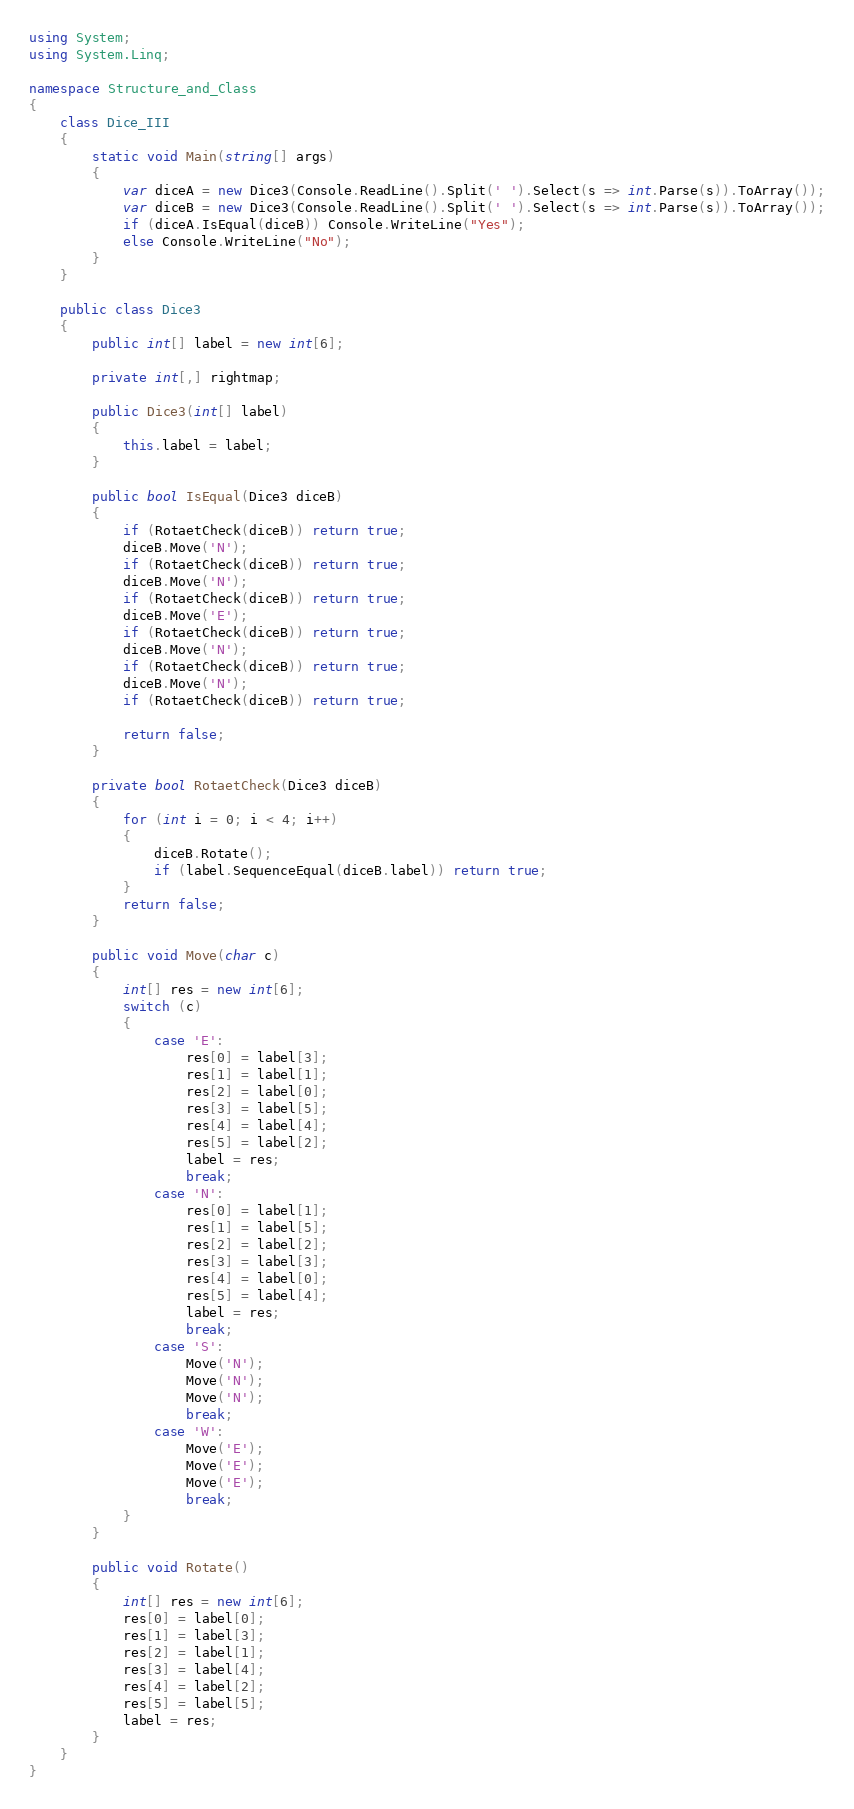Convert code to text. <code><loc_0><loc_0><loc_500><loc_500><_C#_>using System;
using System.Linq;

namespace Structure_and_Class
{
    class Dice_III
    {
        static void Main(string[] args)
        {
            var diceA = new Dice3(Console.ReadLine().Split(' ').Select(s => int.Parse(s)).ToArray());
            var diceB = new Dice3(Console.ReadLine().Split(' ').Select(s => int.Parse(s)).ToArray());
            if (diceA.IsEqual(diceB)) Console.WriteLine("Yes");
            else Console.WriteLine("No");
        }
    }

    public class Dice3
    {
        public int[] label = new int[6];

        private int[,] rightmap;

        public Dice3(int[] label)
        {
            this.label = label;
        }

        public bool IsEqual(Dice3 diceB)
        {
            if (RotaetCheck(diceB)) return true;
            diceB.Move('N');
            if (RotaetCheck(diceB)) return true;
            diceB.Move('N');
            if (RotaetCheck(diceB)) return true;
            diceB.Move('E');
            if (RotaetCheck(diceB)) return true;
            diceB.Move('N');
            if (RotaetCheck(diceB)) return true;
            diceB.Move('N');
            if (RotaetCheck(diceB)) return true;

            return false;
        }

        private bool RotaetCheck(Dice3 diceB)
        {
            for (int i = 0; i < 4; i++)
            {
                diceB.Rotate();
                if (label.SequenceEqual(diceB.label)) return true;
            }
            return false;
        }

        public void Move(char c)
        {
            int[] res = new int[6];
            switch (c)
            {
                case 'E':
                    res[0] = label[3];
                    res[1] = label[1];
                    res[2] = label[0];
                    res[3] = label[5];
                    res[4] = label[4];
                    res[5] = label[2];
                    label = res;
                    break;
                case 'N':
                    res[0] = label[1];
                    res[1] = label[5];
                    res[2] = label[2];
                    res[3] = label[3];
                    res[4] = label[0];
                    res[5] = label[4];
                    label = res;
                    break;
                case 'S':
                    Move('N');
                    Move('N');
                    Move('N');
                    break;
                case 'W':
                    Move('E');
                    Move('E');
                    Move('E');
                    break;
            }
        }

        public void Rotate()
        {
            int[] res = new int[6];
            res[0] = label[0];
            res[1] = label[3];
            res[2] = label[1];
            res[3] = label[4];
            res[4] = label[2];
            res[5] = label[5];
            label = res;
        }
    }
}</code> 